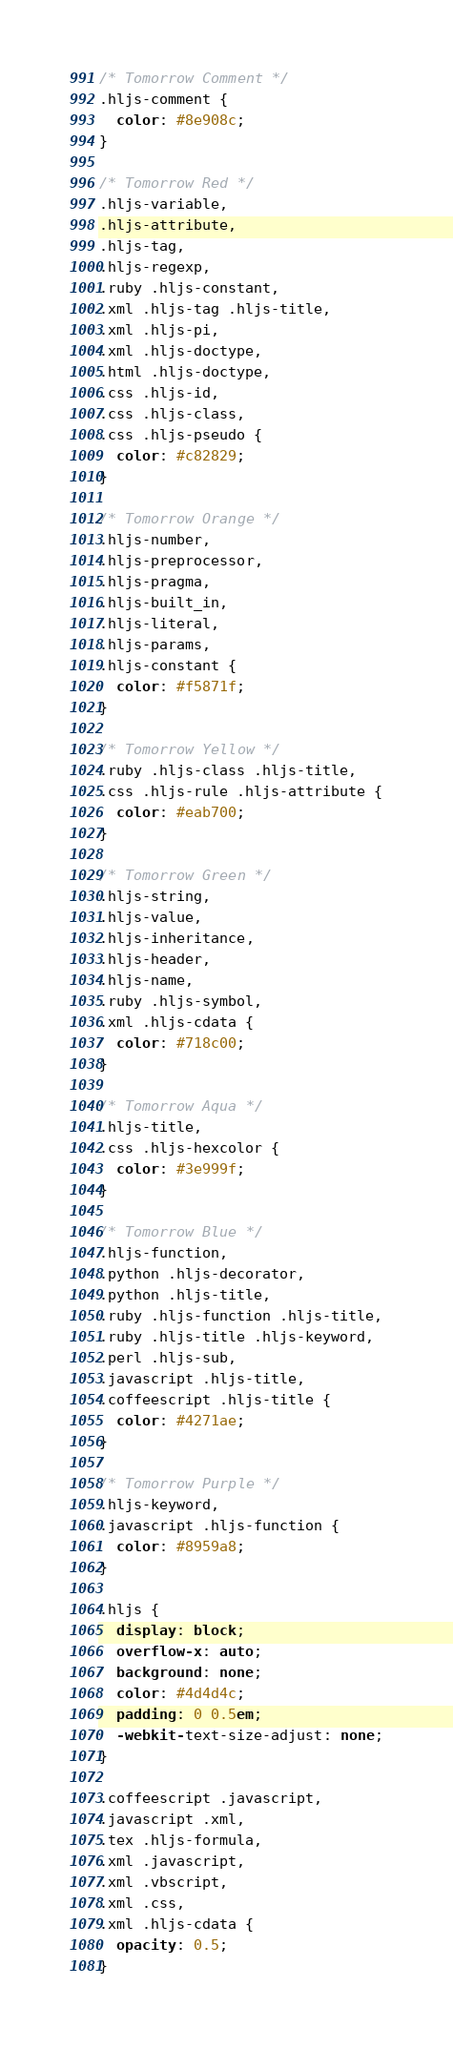<code> <loc_0><loc_0><loc_500><loc_500><_CSS_>
/* Tomorrow Comment */
.hljs-comment {
  color: #8e908c;
}

/* Tomorrow Red */
.hljs-variable,
.hljs-attribute,
.hljs-tag,
.hljs-regexp,
.ruby .hljs-constant,
.xml .hljs-tag .hljs-title,
.xml .hljs-pi,
.xml .hljs-doctype,
.html .hljs-doctype,
.css .hljs-id,
.css .hljs-class,
.css .hljs-pseudo {
  color: #c82829;
}

/* Tomorrow Orange */
.hljs-number,
.hljs-preprocessor,
.hljs-pragma,
.hljs-built_in,
.hljs-literal,
.hljs-params,
.hljs-constant {
  color: #f5871f;
}

/* Tomorrow Yellow */
.ruby .hljs-class .hljs-title,
.css .hljs-rule .hljs-attribute {
  color: #eab700;
}

/* Tomorrow Green */
.hljs-string,
.hljs-value,
.hljs-inheritance,
.hljs-header,
.hljs-name,
.ruby .hljs-symbol,
.xml .hljs-cdata {
  color: #718c00;
}

/* Tomorrow Aqua */
.hljs-title,
.css .hljs-hexcolor {
  color: #3e999f;
}

/* Tomorrow Blue */
.hljs-function,
.python .hljs-decorator,
.python .hljs-title,
.ruby .hljs-function .hljs-title,
.ruby .hljs-title .hljs-keyword,
.perl .hljs-sub,
.javascript .hljs-title,
.coffeescript .hljs-title {
  color: #4271ae;
}

/* Tomorrow Purple */
.hljs-keyword,
.javascript .hljs-function {
  color: #8959a8;
}

.hljs {
  display: block;
  overflow-x: auto;
  background: none;
  color: #4d4d4c;
  padding: 0 0.5em;
  -webkit-text-size-adjust: none;
}

.coffeescript .javascript,
.javascript .xml,
.tex .hljs-formula,
.xml .javascript,
.xml .vbscript,
.xml .css,
.xml .hljs-cdata {
  opacity: 0.5;
}
</code> 